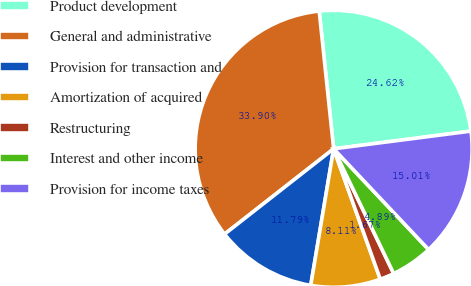Convert chart to OTSL. <chart><loc_0><loc_0><loc_500><loc_500><pie_chart><fcel>Product development<fcel>General and administrative<fcel>Provision for transaction and<fcel>Amortization of acquired<fcel>Restructuring<fcel>Interest and other income<fcel>Provision for income taxes<nl><fcel>24.62%<fcel>33.9%<fcel>11.79%<fcel>8.11%<fcel>1.67%<fcel>4.89%<fcel>15.01%<nl></chart> 